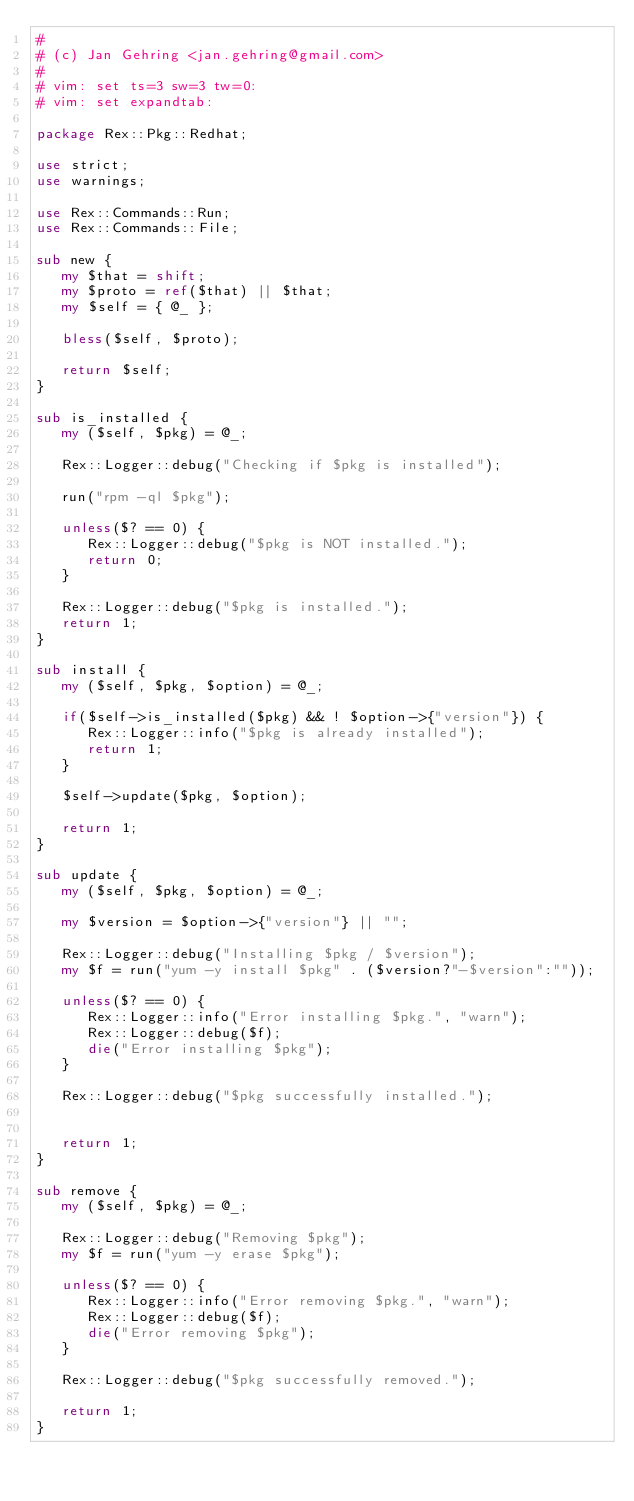<code> <loc_0><loc_0><loc_500><loc_500><_Perl_>#
# (c) Jan Gehring <jan.gehring@gmail.com>
# 
# vim: set ts=3 sw=3 tw=0:
# vim: set expandtab:

package Rex::Pkg::Redhat;

use strict;
use warnings;

use Rex::Commands::Run;
use Rex::Commands::File;

sub new {
   my $that = shift;
   my $proto = ref($that) || $that;
   my $self = { @_ };

   bless($self, $proto);

   return $self;
}

sub is_installed {
   my ($self, $pkg) = @_;

   Rex::Logger::debug("Checking if $pkg is installed");

   run("rpm -ql $pkg");

   unless($? == 0) {
      Rex::Logger::debug("$pkg is NOT installed.");
      return 0;
   }
   
   Rex::Logger::debug("$pkg is installed.");
   return 1;
}

sub install {
   my ($self, $pkg, $option) = @_;

   if($self->is_installed($pkg) && ! $option->{"version"}) {
      Rex::Logger::info("$pkg is already installed");
      return 1;
   }

   $self->update($pkg, $option);

   return 1;
}

sub update {
   my ($self, $pkg, $option) = @_;

   my $version = $option->{"version"} || "";

   Rex::Logger::debug("Installing $pkg / $version");
   my $f = run("yum -y install $pkg" . ($version?"-$version":""));

   unless($? == 0) {
      Rex::Logger::info("Error installing $pkg.", "warn");
      Rex::Logger::debug($f);
      die("Error installing $pkg");
   }

   Rex::Logger::debug("$pkg successfully installed.");


   return 1;
}

sub remove {
   my ($self, $pkg) = @_;

   Rex::Logger::debug("Removing $pkg");
   my $f = run("yum -y erase $pkg");

   unless($? == 0) {
      Rex::Logger::info("Error removing $pkg.", "warn");
      Rex::Logger::debug($f);
      die("Error removing $pkg");
   }

   Rex::Logger::debug("$pkg successfully removed.");

   return 1;
}
</code> 